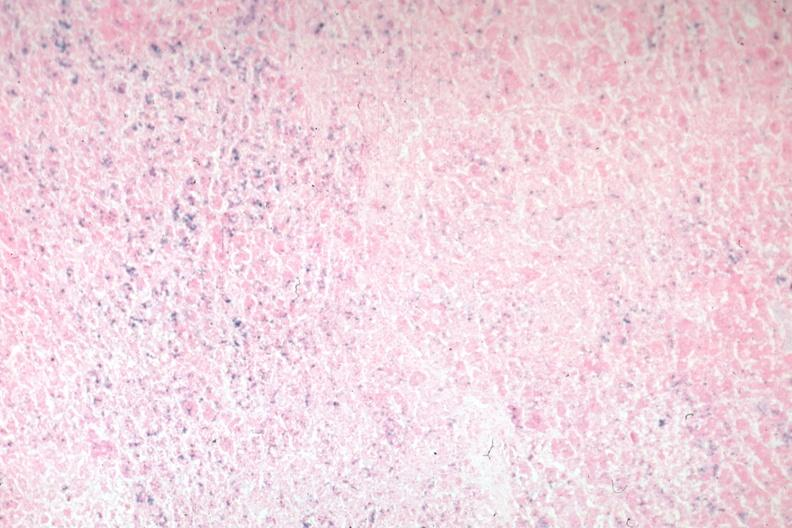where is this part in the figure?
Answer the question using a single word or phrase. Endocrine system 